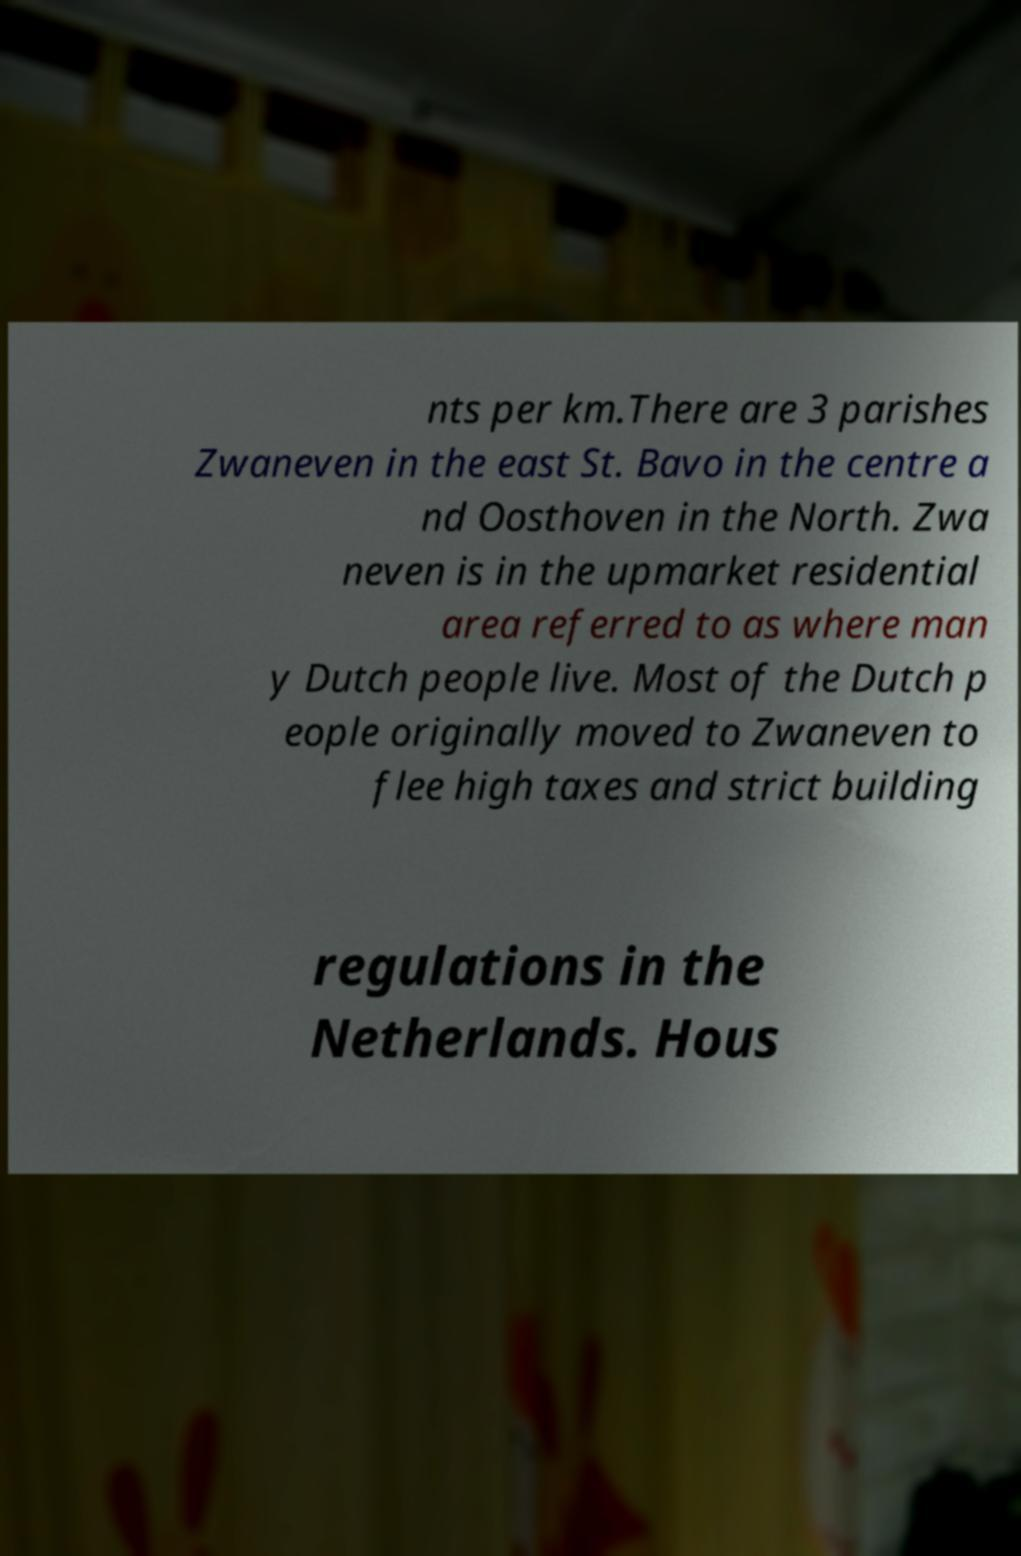Could you extract and type out the text from this image? nts per km.There are 3 parishes Zwaneven in the east St. Bavo in the centre a nd Oosthoven in the North. Zwa neven is in the upmarket residential area referred to as where man y Dutch people live. Most of the Dutch p eople originally moved to Zwaneven to flee high taxes and strict building regulations in the Netherlands. Hous 